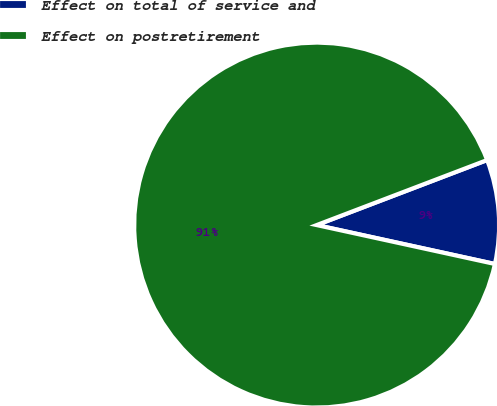Convert chart. <chart><loc_0><loc_0><loc_500><loc_500><pie_chart><fcel>Effect on total of service and<fcel>Effect on postretirement<nl><fcel>9.22%<fcel>90.78%<nl></chart> 